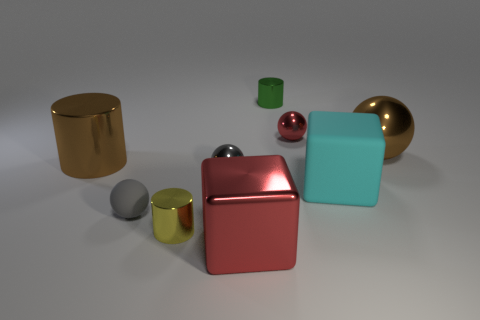Does the large cylinder have the same color as the big metal ball?
Provide a succinct answer. Yes. What material is the thing that is the same color as the large metal cube?
Offer a terse response. Metal. What number of other objects are there of the same color as the large matte cube?
Make the answer very short. 0. There is a thing that is to the left of the matte block and to the right of the green metallic cylinder; what is its shape?
Your response must be concise. Sphere. Are there any yellow cylinders that are left of the brown metallic cylinder that is in front of the red thing right of the green cylinder?
Provide a short and direct response. No. How many other objects are the same material as the small red thing?
Your answer should be very brief. 6. What number of tiny rubber objects are there?
Give a very brief answer. 1. What number of things are either big brown metallic objects or small shiny balls that are in front of the green metallic object?
Your response must be concise. 4. There is a shiny cylinder in front of the brown metal cylinder; is its size the same as the small green object?
Provide a short and direct response. Yes. What number of metal objects are gray things or green things?
Give a very brief answer. 2. 